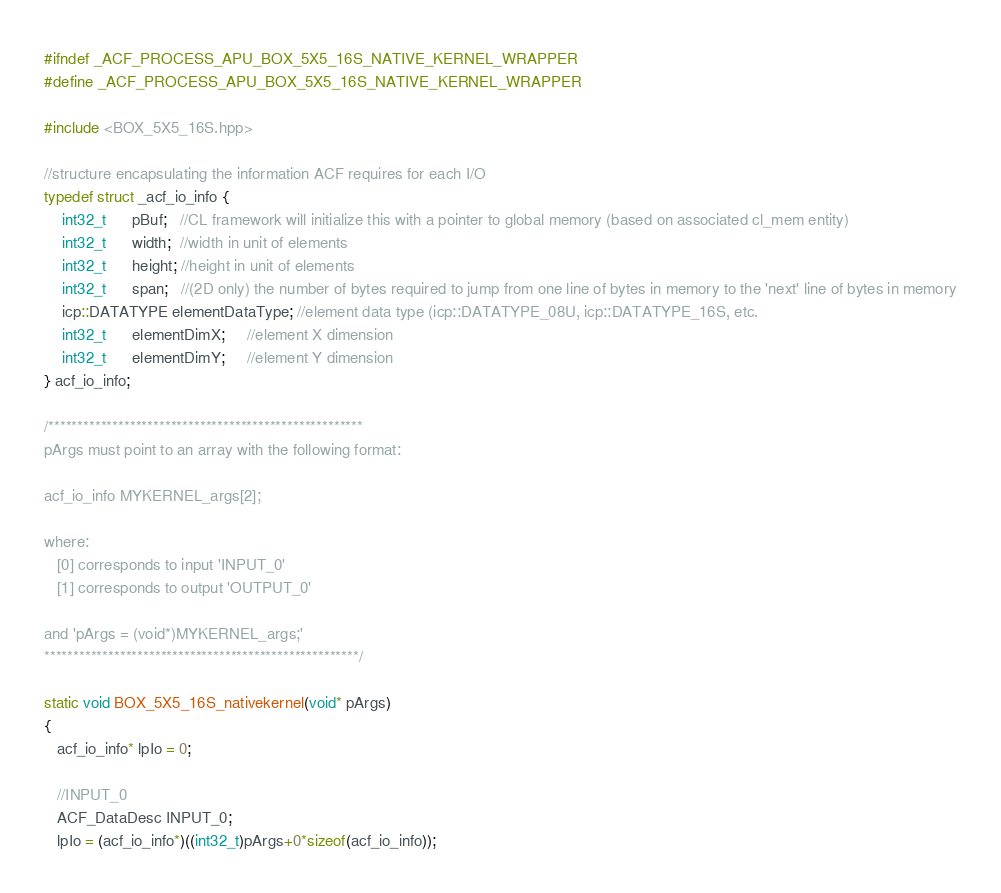Convert code to text. <code><loc_0><loc_0><loc_500><loc_500><_C++_>#ifndef _ACF_PROCESS_APU_BOX_5X5_16S_NATIVE_KERNEL_WRAPPER
#define _ACF_PROCESS_APU_BOX_5X5_16S_NATIVE_KERNEL_WRAPPER

#include <BOX_5X5_16S.hpp>

//structure encapsulating the information ACF requires for each I/O
typedef struct _acf_io_info {                                      
    int32_t      pBuf;   //CL framework will initialize this with a pointer to global memory (based on associated cl_mem entity)
    int32_t      width;  //width in unit of elements
    int32_t      height; //height in unit of elements
    int32_t      span;   //(2D only) the number of bytes required to jump from one line of bytes in memory to the 'next' line of bytes in memory
    icp::DATATYPE elementDataType; //element data type (icp::DATATYPE_08U, icp::DATATYPE_16S, etc.
    int32_t      elementDimX;     //element X dimension
    int32_t      elementDimY;     //element Y dimension
} acf_io_info;

/******************************************************
pArgs must point to an array with the following format:

acf_io_info MYKERNEL_args[2];

where:
   [0] corresponds to input 'INPUT_0'
   [1] corresponds to output 'OUTPUT_0'

and 'pArgs = (void*)MYKERNEL_args;'
******************************************************/

static void BOX_5X5_16S_nativekernel(void* pArgs)
{
   acf_io_info* lpIo = 0;

   //INPUT_0
   ACF_DataDesc INPUT_0;
   lpIo = (acf_io_info*)((int32_t)pArgs+0*sizeof(acf_io_info));</code> 